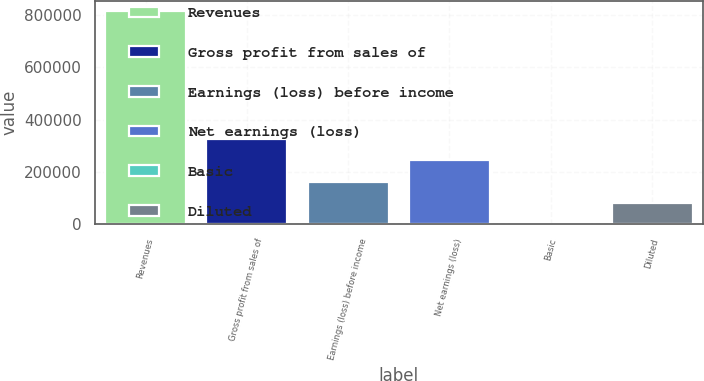Convert chart. <chart><loc_0><loc_0><loc_500><loc_500><bar_chart><fcel>Revenues<fcel>Gross profit from sales of<fcel>Earnings (loss) before income<fcel>Net earnings (loss)<fcel>Basic<fcel>Diluted<nl><fcel>814481<fcel>325793<fcel>162896<fcel>244344<fcel>0.21<fcel>81448.3<nl></chart> 